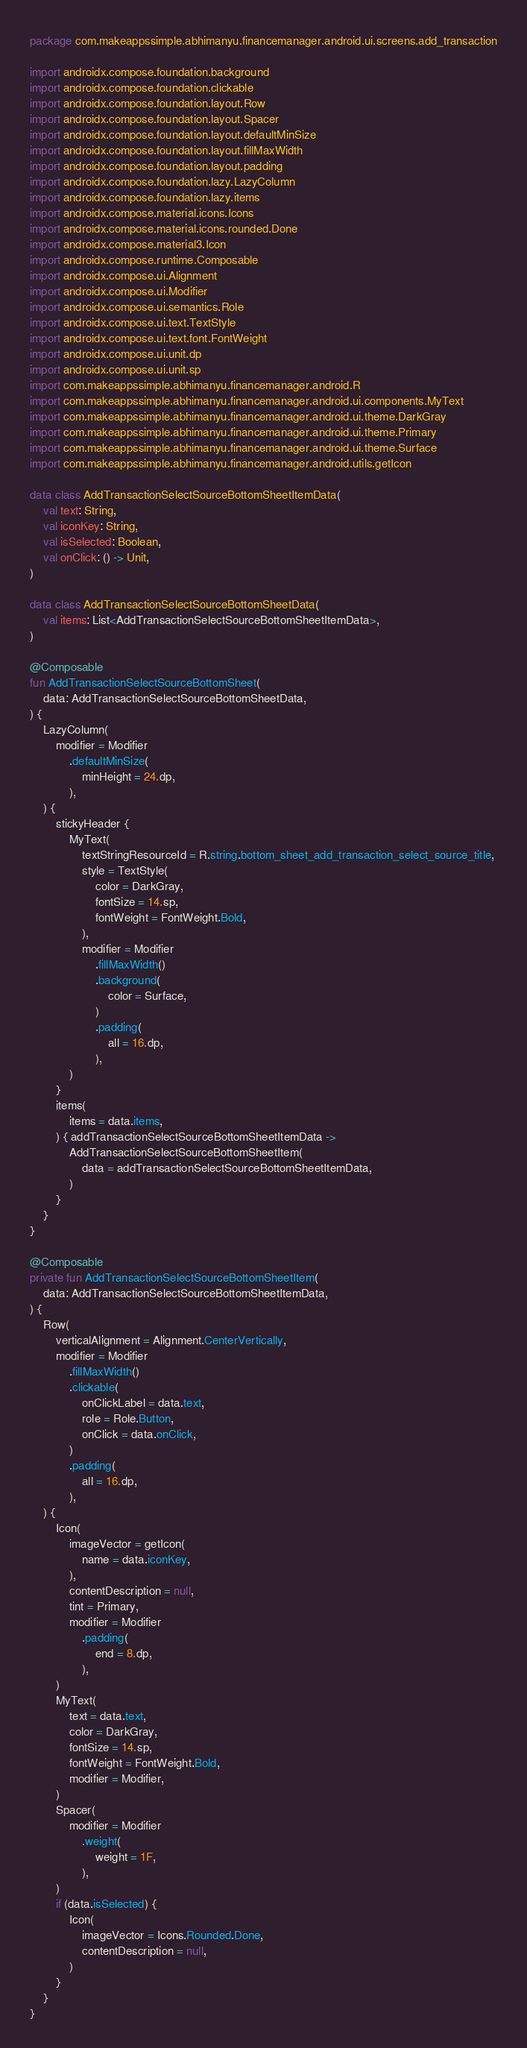<code> <loc_0><loc_0><loc_500><loc_500><_Kotlin_>package com.makeappssimple.abhimanyu.financemanager.android.ui.screens.add_transaction

import androidx.compose.foundation.background
import androidx.compose.foundation.clickable
import androidx.compose.foundation.layout.Row
import androidx.compose.foundation.layout.Spacer
import androidx.compose.foundation.layout.defaultMinSize
import androidx.compose.foundation.layout.fillMaxWidth
import androidx.compose.foundation.layout.padding
import androidx.compose.foundation.lazy.LazyColumn
import androidx.compose.foundation.lazy.items
import androidx.compose.material.icons.Icons
import androidx.compose.material.icons.rounded.Done
import androidx.compose.material3.Icon
import androidx.compose.runtime.Composable
import androidx.compose.ui.Alignment
import androidx.compose.ui.Modifier
import androidx.compose.ui.semantics.Role
import androidx.compose.ui.text.TextStyle
import androidx.compose.ui.text.font.FontWeight
import androidx.compose.ui.unit.dp
import androidx.compose.ui.unit.sp
import com.makeappssimple.abhimanyu.financemanager.android.R
import com.makeappssimple.abhimanyu.financemanager.android.ui.components.MyText
import com.makeappssimple.abhimanyu.financemanager.android.ui.theme.DarkGray
import com.makeappssimple.abhimanyu.financemanager.android.ui.theme.Primary
import com.makeappssimple.abhimanyu.financemanager.android.ui.theme.Surface
import com.makeappssimple.abhimanyu.financemanager.android.utils.getIcon

data class AddTransactionSelectSourceBottomSheetItemData(
    val text: String,
    val iconKey: String,
    val isSelected: Boolean,
    val onClick: () -> Unit,
)

data class AddTransactionSelectSourceBottomSheetData(
    val items: List<AddTransactionSelectSourceBottomSheetItemData>,
)

@Composable
fun AddTransactionSelectSourceBottomSheet(
    data: AddTransactionSelectSourceBottomSheetData,
) {
    LazyColumn(
        modifier = Modifier
            .defaultMinSize(
                minHeight = 24.dp,
            ),
    ) {
        stickyHeader {
            MyText(
                textStringResourceId = R.string.bottom_sheet_add_transaction_select_source_title,
                style = TextStyle(
                    color = DarkGray,
                    fontSize = 14.sp,
                    fontWeight = FontWeight.Bold,
                ),
                modifier = Modifier
                    .fillMaxWidth()
                    .background(
                        color = Surface,
                    )
                    .padding(
                        all = 16.dp,
                    ),
            )
        }
        items(
            items = data.items,
        ) { addTransactionSelectSourceBottomSheetItemData ->
            AddTransactionSelectSourceBottomSheetItem(
                data = addTransactionSelectSourceBottomSheetItemData,
            )
        }
    }
}

@Composable
private fun AddTransactionSelectSourceBottomSheetItem(
    data: AddTransactionSelectSourceBottomSheetItemData,
) {
    Row(
        verticalAlignment = Alignment.CenterVertically,
        modifier = Modifier
            .fillMaxWidth()
            .clickable(
                onClickLabel = data.text,
                role = Role.Button,
                onClick = data.onClick,
            )
            .padding(
                all = 16.dp,
            ),
    ) {
        Icon(
            imageVector = getIcon(
                name = data.iconKey,
            ),
            contentDescription = null,
            tint = Primary,
            modifier = Modifier
                .padding(
                    end = 8.dp,
                ),
        )
        MyText(
            text = data.text,
            color = DarkGray,
            fontSize = 14.sp,
            fontWeight = FontWeight.Bold,
            modifier = Modifier,
        )
        Spacer(
            modifier = Modifier
                .weight(
                    weight = 1F,
                ),
        )
        if (data.isSelected) {
            Icon(
                imageVector = Icons.Rounded.Done,
                contentDescription = null,
            )
        }
    }
}
</code> 